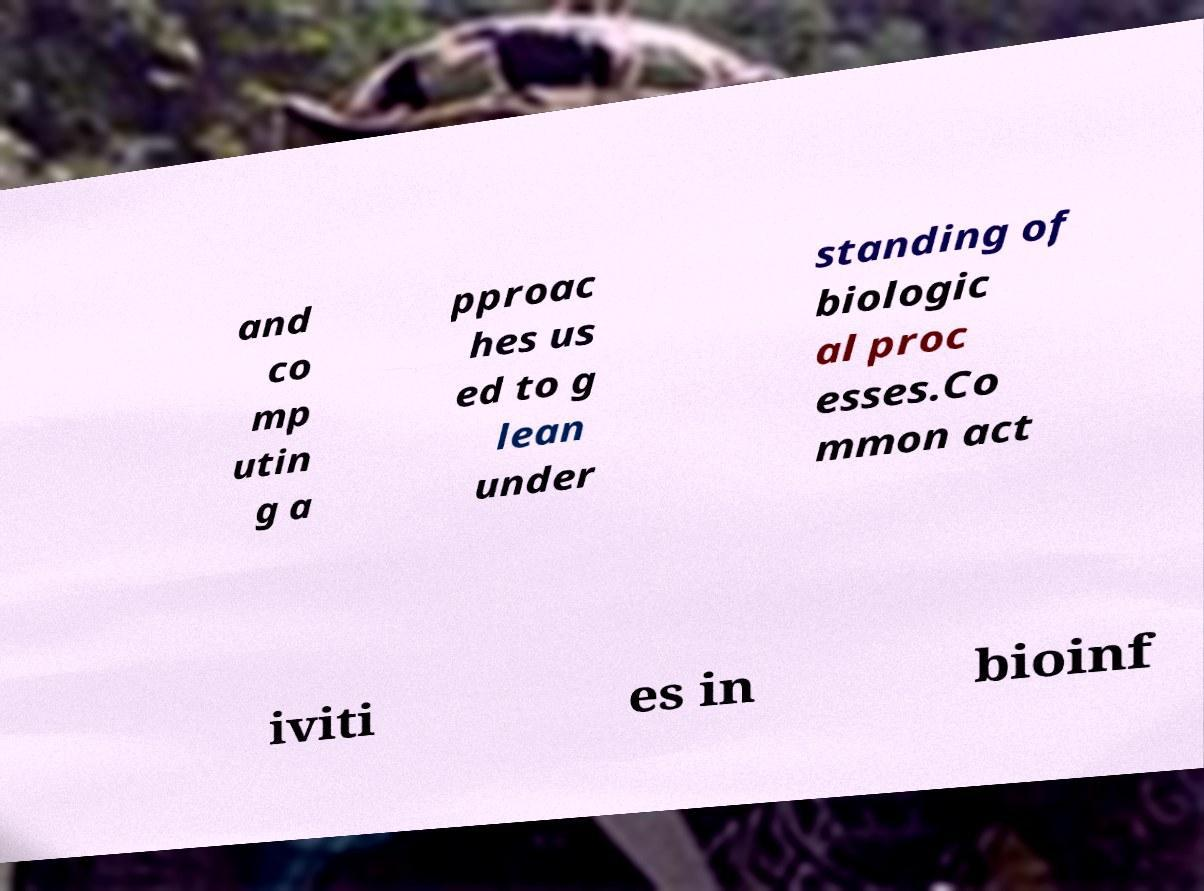What messages or text are displayed in this image? I need them in a readable, typed format. and co mp utin g a pproac hes us ed to g lean under standing of biologic al proc esses.Co mmon act iviti es in bioinf 